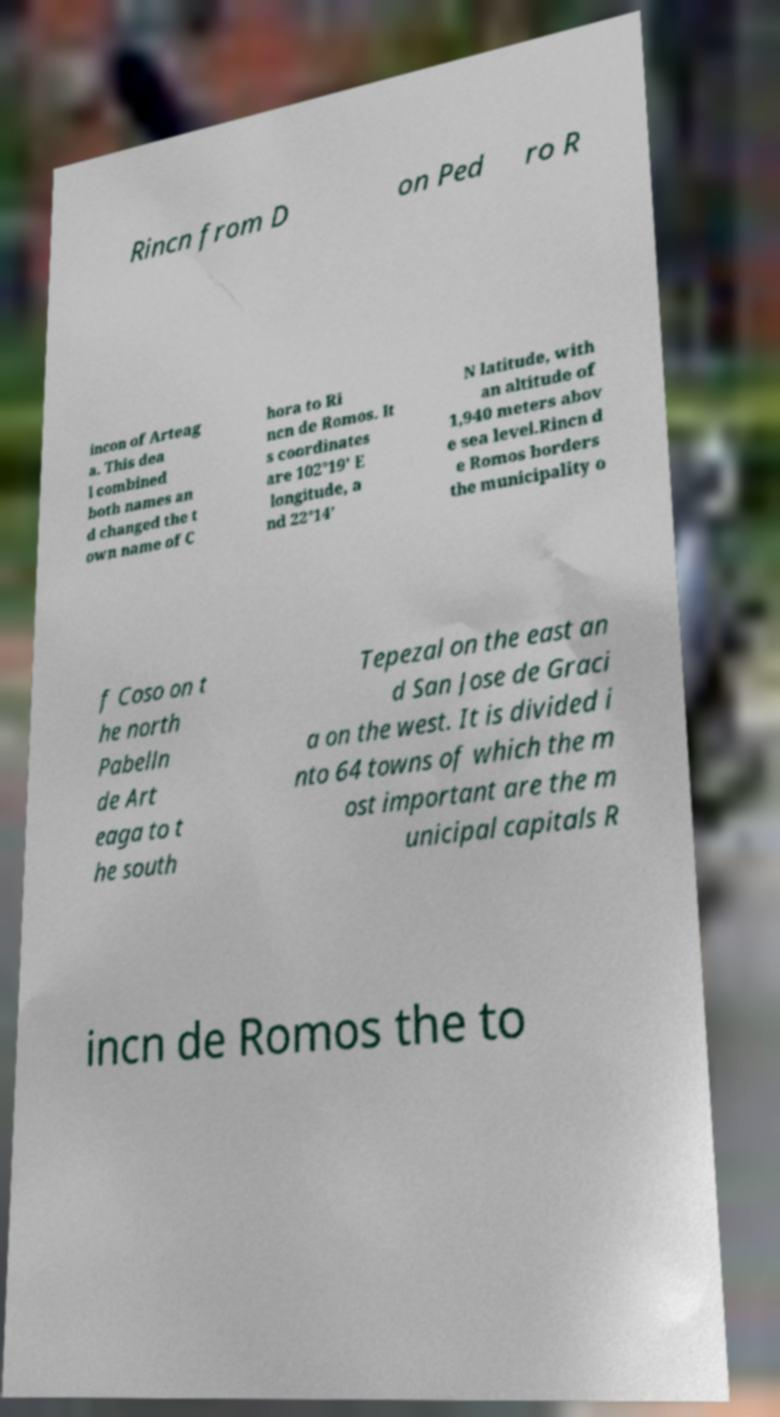Can you accurately transcribe the text from the provided image for me? Rincn from D on Ped ro R incon of Arteag a. This dea l combined both names an d changed the t own name of C hora to Ri ncn de Romos. It s coordinates are 102°19’ E longitude, a nd 22°14’ N latitude, with an altitude of 1,940 meters abov e sea level.Rincn d e Romos borders the municipality o f Coso on t he north Pabelln de Art eaga to t he south Tepezal on the east an d San Jose de Graci a on the west. It is divided i nto 64 towns of which the m ost important are the m unicipal capitals R incn de Romos the to 